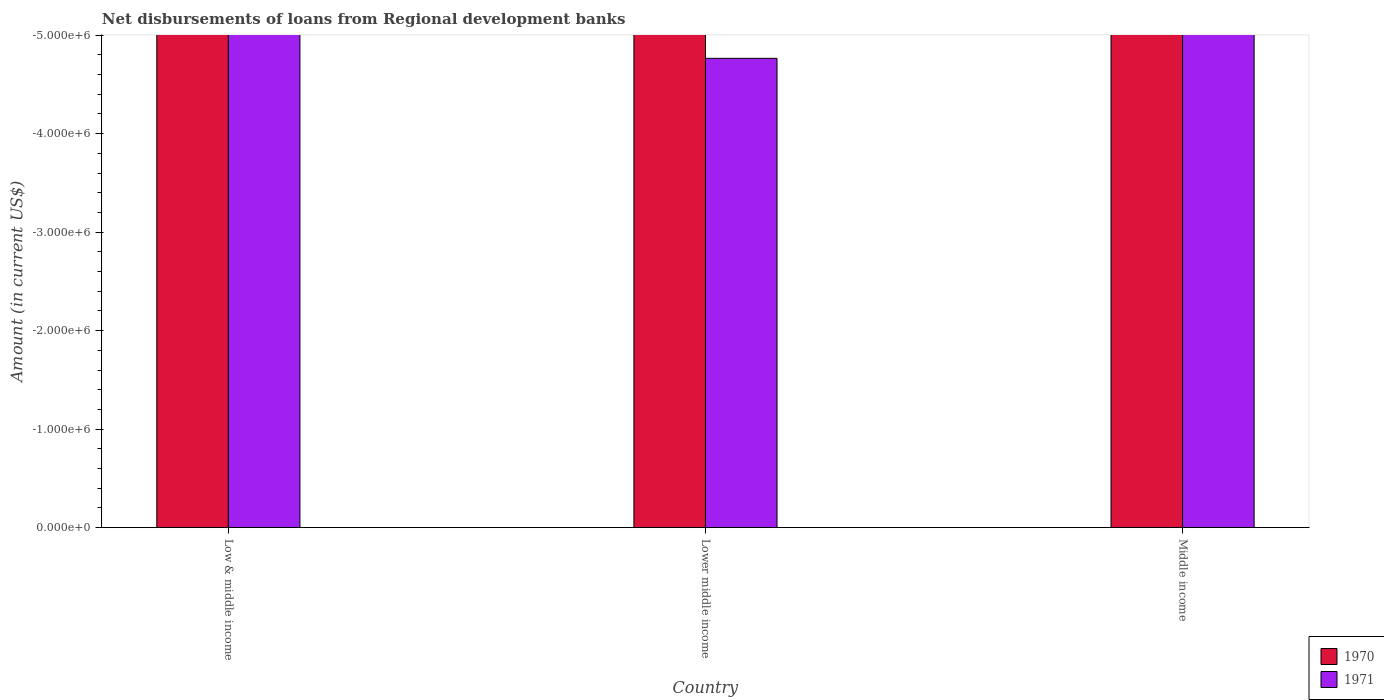How many different coloured bars are there?
Your response must be concise. 0. Are the number of bars per tick equal to the number of legend labels?
Your response must be concise. No. Are the number of bars on each tick of the X-axis equal?
Ensure brevity in your answer.  Yes. How many bars are there on the 3rd tick from the right?
Your response must be concise. 0. What is the label of the 2nd group of bars from the left?
Your answer should be very brief. Lower middle income. What is the amount of disbursements of loans from regional development banks in 1971 in Low & middle income?
Give a very brief answer. 0. What is the total amount of disbursements of loans from regional development banks in 1971 in the graph?
Provide a succinct answer. 0. What is the average amount of disbursements of loans from regional development banks in 1971 per country?
Ensure brevity in your answer.  0. In how many countries, is the amount of disbursements of loans from regional development banks in 1970 greater than -2000000 US$?
Give a very brief answer. 0. In how many countries, is the amount of disbursements of loans from regional development banks in 1971 greater than the average amount of disbursements of loans from regional development banks in 1971 taken over all countries?
Your answer should be very brief. 0. How many bars are there?
Provide a short and direct response. 0. Are all the bars in the graph horizontal?
Provide a short and direct response. No. What is the difference between two consecutive major ticks on the Y-axis?
Your answer should be compact. 1.00e+06. Are the values on the major ticks of Y-axis written in scientific E-notation?
Provide a succinct answer. Yes. Does the graph contain any zero values?
Ensure brevity in your answer.  Yes. Does the graph contain grids?
Provide a succinct answer. No. Where does the legend appear in the graph?
Provide a short and direct response. Bottom right. How many legend labels are there?
Offer a terse response. 2. How are the legend labels stacked?
Your answer should be compact. Vertical. What is the title of the graph?
Offer a very short reply. Net disbursements of loans from Regional development banks. Does "1965" appear as one of the legend labels in the graph?
Your response must be concise. No. What is the label or title of the X-axis?
Make the answer very short. Country. What is the label or title of the Y-axis?
Your response must be concise. Amount (in current US$). What is the Amount (in current US$) of 1971 in Middle income?
Your answer should be very brief. 0. What is the average Amount (in current US$) in 1970 per country?
Ensure brevity in your answer.  0. 